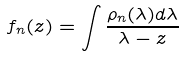<formula> <loc_0><loc_0><loc_500><loc_500>f _ { n } ( z ) = \int { \frac { \rho _ { n } ( \lambda ) d \lambda } { \lambda - z } }</formula> 